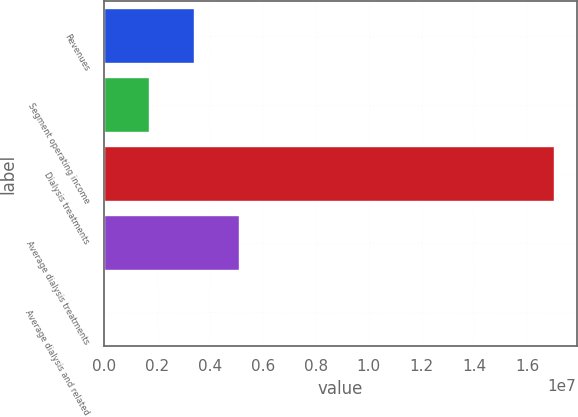Convert chart. <chart><loc_0><loc_0><loc_500><loc_500><bar_chart><fcel>Revenues<fcel>Segment operating income<fcel>Dialysis treatments<fcel>Average dialysis treatments<fcel>Average dialysis and related<nl><fcel>3.40236e+06<fcel>1.70135e+06<fcel>1.70104e+07<fcel>5.10337e+06<fcel>340<nl></chart> 